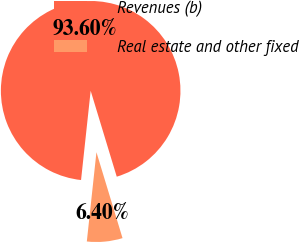Convert chart. <chart><loc_0><loc_0><loc_500><loc_500><pie_chart><fcel>Revenues (b)<fcel>Real estate and other fixed<nl><fcel>93.6%<fcel>6.4%<nl></chart> 